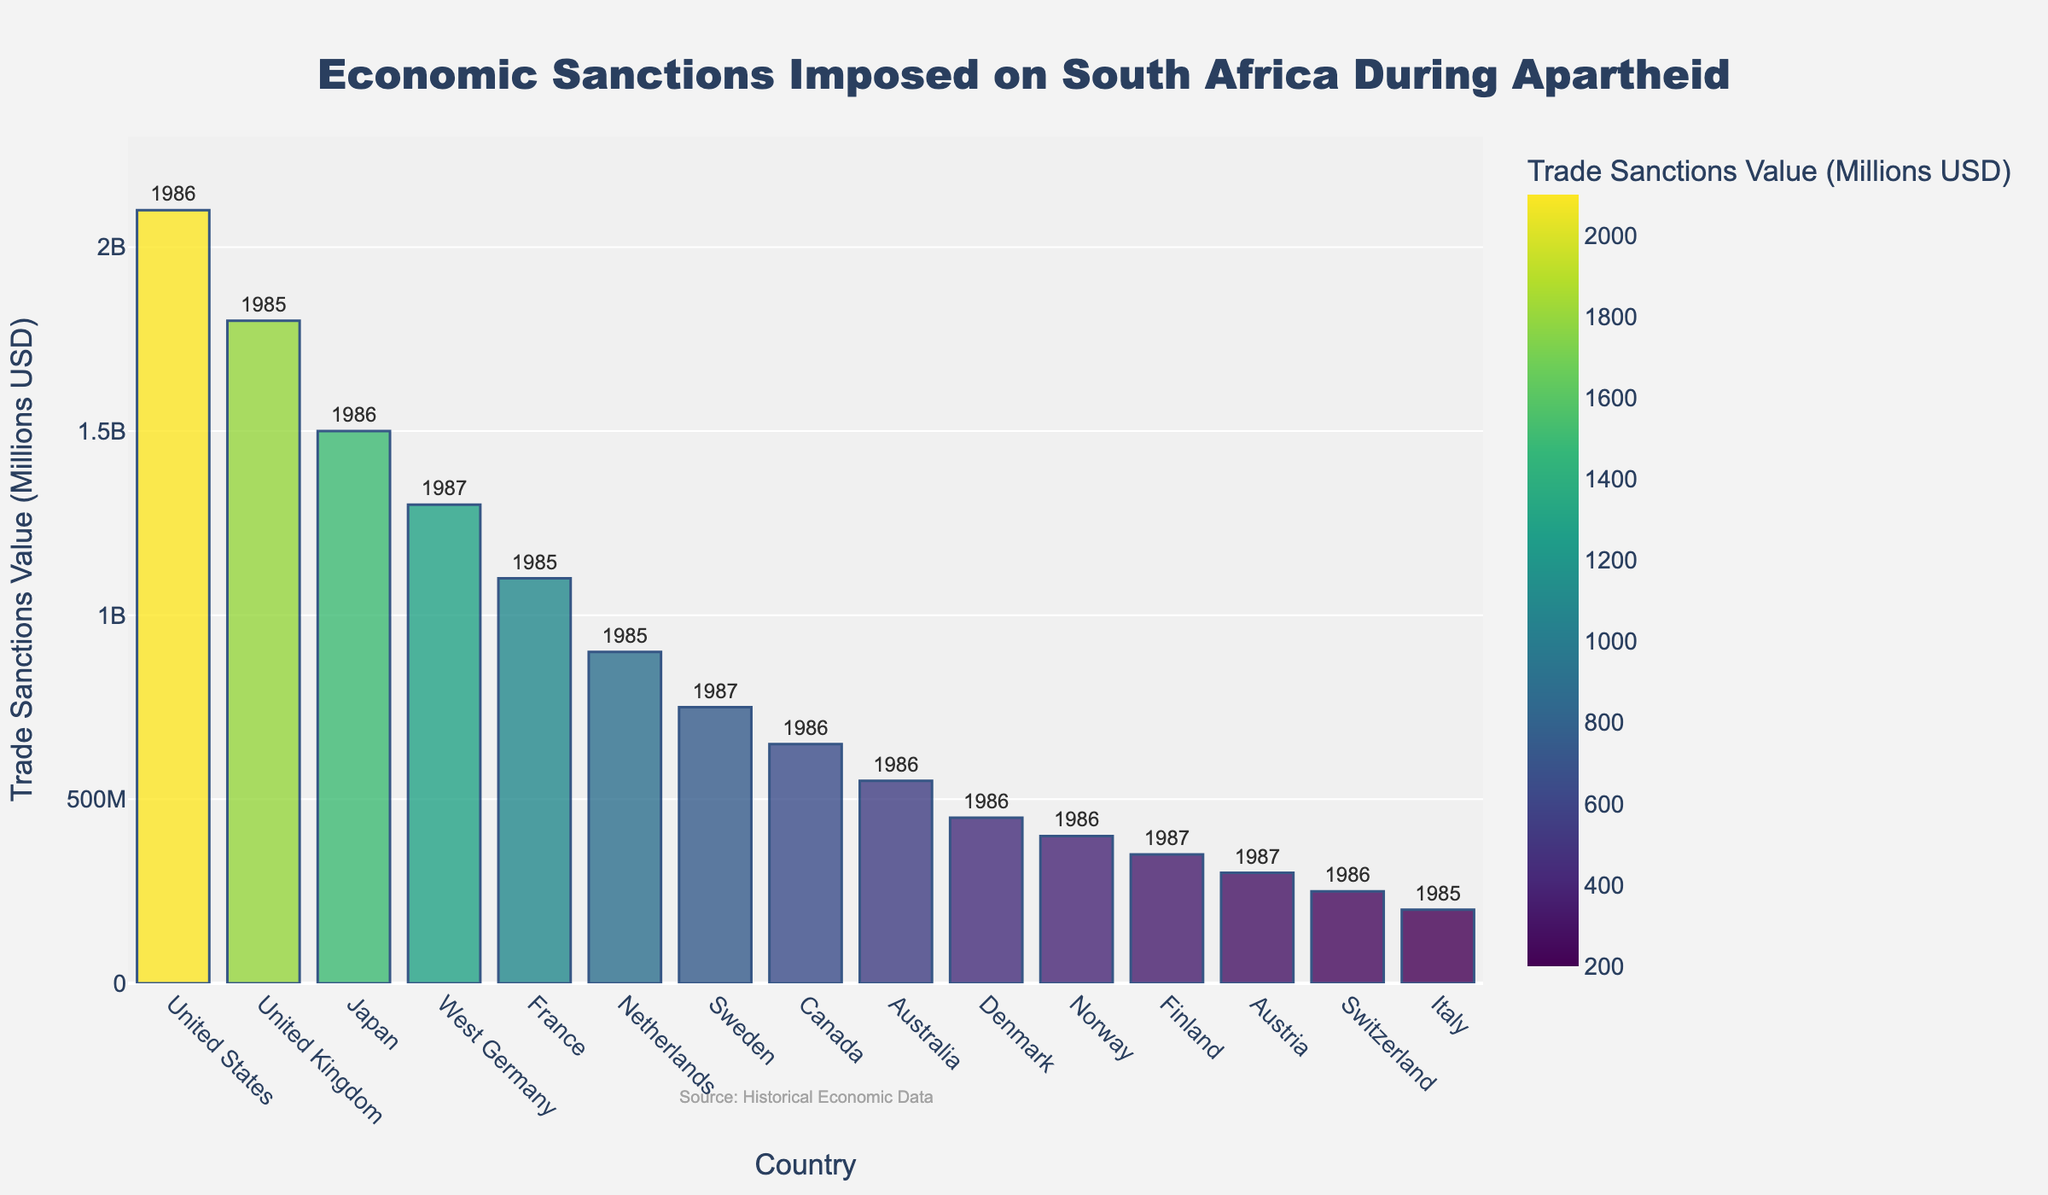Which country imposed the highest value of trade sanctions on South Africa during apartheid? The country with the highest bar in the chart represents the highest value of trade sanctions. The United States has the tallest bar indicating a value of 2100 million USD.
Answer: United States Which year saw the most countries impose trade sanctions on South Africa? Count the number of countries that imposed trade sanctions in each year based on the text annotations on the bars. The year 1986 has the most entries (United States, Japan, Canada, Australia, Denmark, Norway, Switzerland), totaling 7 countries.
Answer: 1986 What is the combined value of trade sanctions imposed by France, the Netherlands, and Italy? Sum the trade sanctions values for France (1100), the Netherlands (900), and Italy (200): 1100 + 900 + 200 = 2200
Answer: 2200 Compare the trade sanctions values between the United Kingdom and West Germany. Which country imposed a higher value and by how much? The value for the United Kingdom is 1800 million USD, and for West Germany, it is 1300 million USD. The difference is 1800 - 1300 = 500
Answer: United Kingdom by 500 Which country imposed the lowest value of trade sanctions on South Africa, and what was the value? The country with the shortest bar represents the lowest value of trade sanctions. Italy has the shortest bar indicating a value of 200 million USD.
Answer: Italy, 200 What is the average value of trade sanctions imposed by the top three countries with the highest values? Sum the trade sanctions values of the top three countries (United States: 2100, United Kingdom: 1800, Japan: 1500) and then divide by 3: (2100 + 1800 + 1500) / 3 = 5400 / 3 = 1800
Answer: 1800 How do the heights of the bars for Canada and Australia compare visually? The bars for Canada and Australia are both in the middle section of the chart. Count the units represented by each bar: Canada (650) and Australia (550). The bar for Canada is taller.
Answer: Canada What is the difference in the trade sanctions value between Sweden and Switzerland? The value for Sweden is 750 million USD, and for Switzerland, it is 250 million USD. The difference is 750 - 250 = 500
Answer: 500 Which country from the chart imposed trade sanctions in both 1985 and 1986? Scan the chart for countries with bars labeled with both years. None of the countries imposed sanctions in both years.
Answer: None 